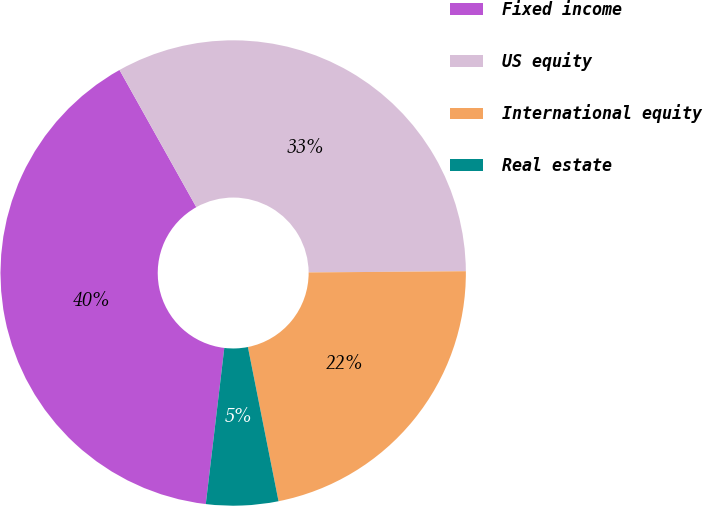Convert chart. <chart><loc_0><loc_0><loc_500><loc_500><pie_chart><fcel>Fixed income<fcel>US equity<fcel>International equity<fcel>Real estate<nl><fcel>40.0%<fcel>33.0%<fcel>22.0%<fcel>5.0%<nl></chart> 